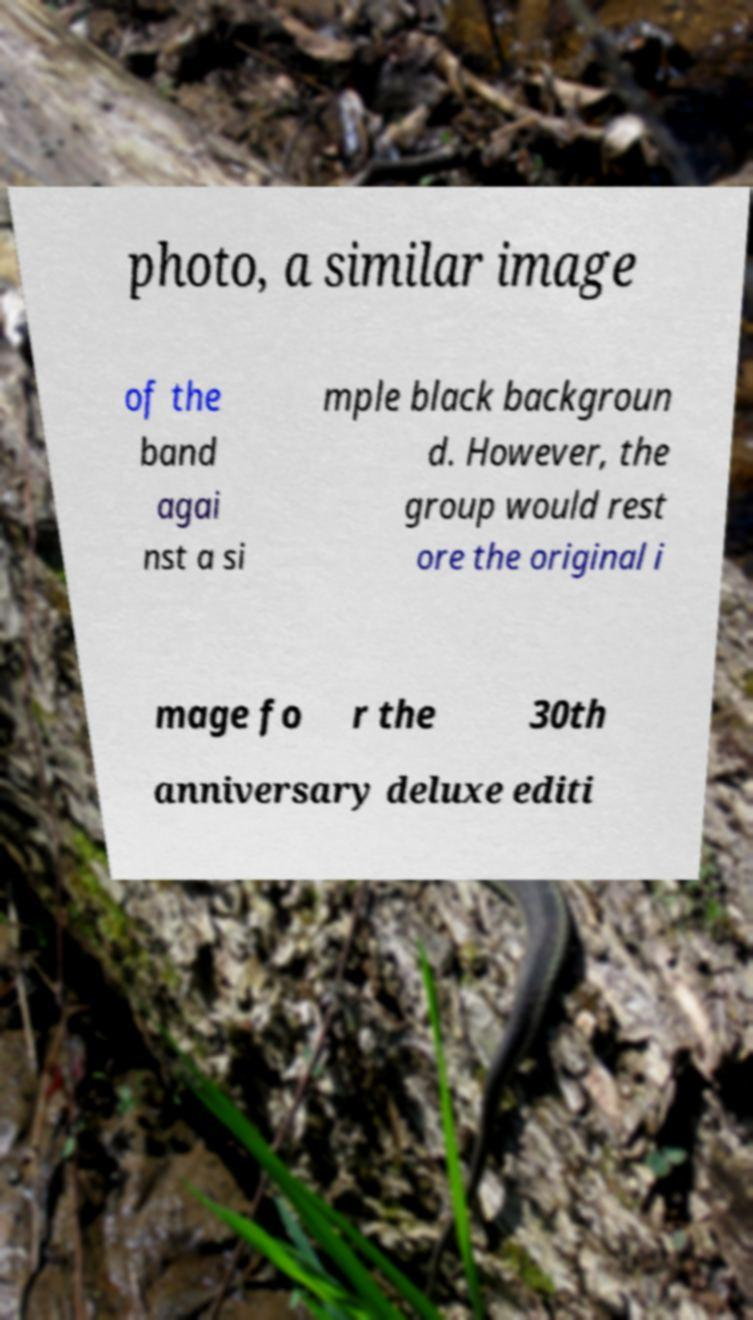Can you read and provide the text displayed in the image?This photo seems to have some interesting text. Can you extract and type it out for me? photo, a similar image of the band agai nst a si mple black backgroun d. However, the group would rest ore the original i mage fo r the 30th anniversary deluxe editi 